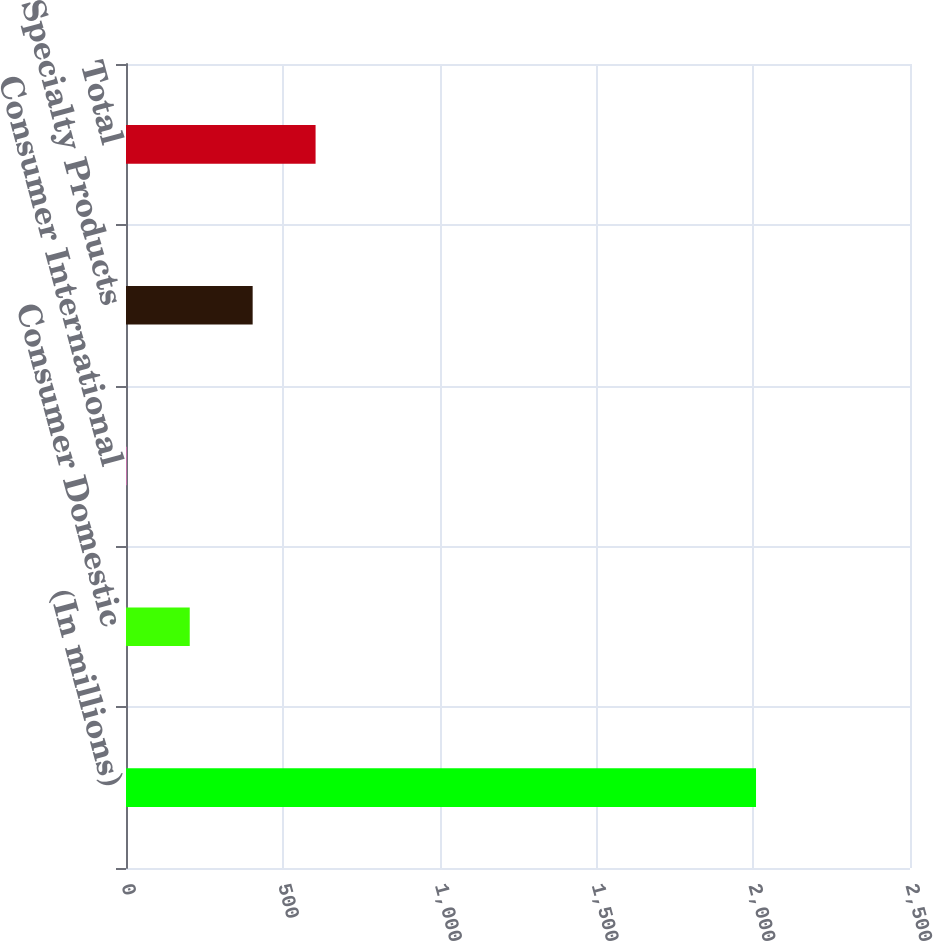<chart> <loc_0><loc_0><loc_500><loc_500><bar_chart><fcel>(In millions)<fcel>Consumer Domestic<fcel>Consumer International<fcel>Specialty Products<fcel>Total<nl><fcel>2009<fcel>203.24<fcel>2.6<fcel>403.88<fcel>604.52<nl></chart> 